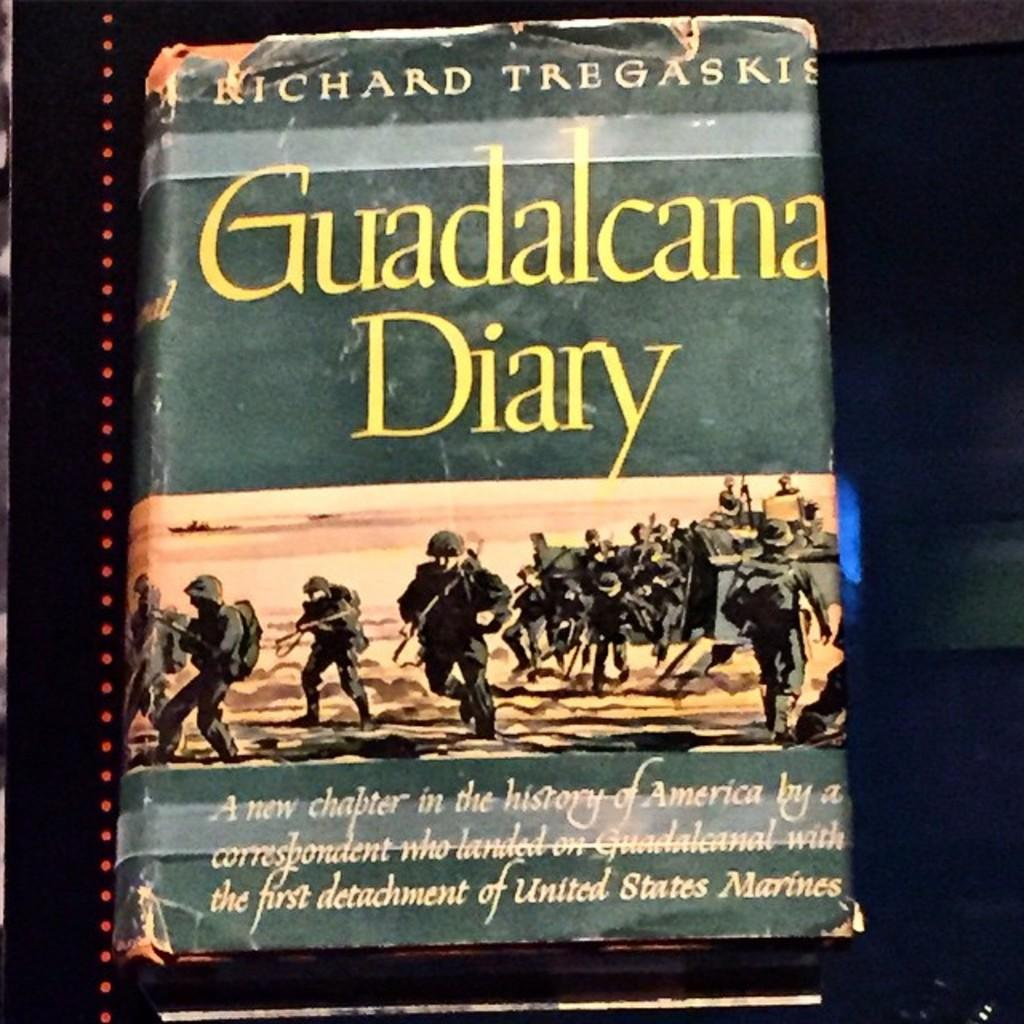What is present on the image that can be read or contains text? There is a book in the image, and the cover page of the book has words. What is depicted on the cover page of the book? The cover page of the book has an image of a group of people. What is the book placed on in the image? The book is placed on an object. What type of quill is used by the people in the image? There is no quill present in the image; it only shows an image of a group of people on the book's cover page. 